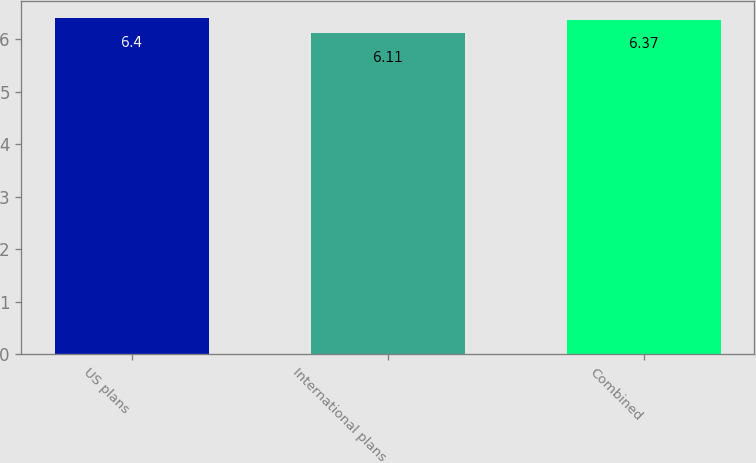<chart> <loc_0><loc_0><loc_500><loc_500><bar_chart><fcel>US plans<fcel>International plans<fcel>Combined<nl><fcel>6.4<fcel>6.11<fcel>6.37<nl></chart> 